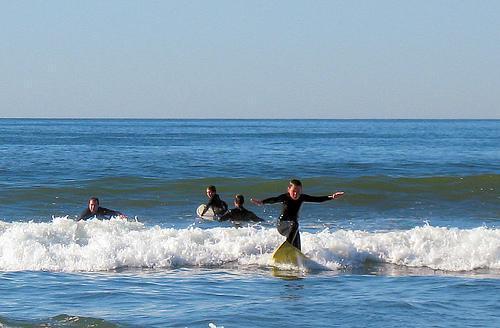How many people are wearing black?
Give a very brief answer. 4. 